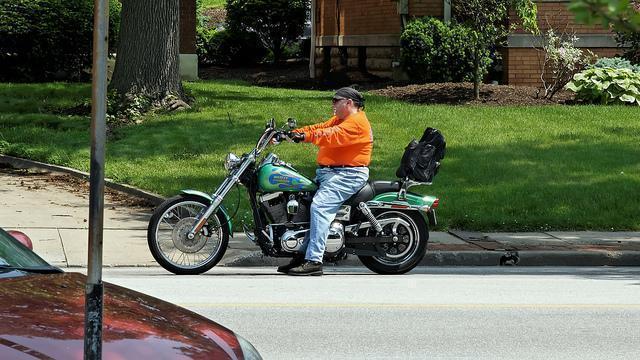What is on the back of the motorcycle?
Indicate the correct response and explain using: 'Answer: answer
Rationale: rationale.'
Options: Suitcase, animal, backpack, person. Answer: backpack.
Rationale: It's small luggage. 